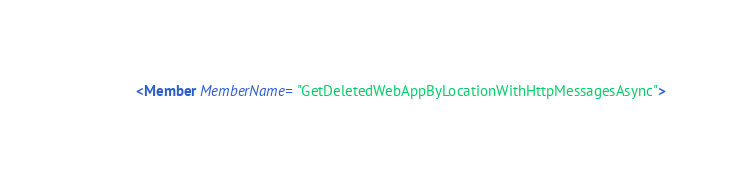Convert code to text. <code><loc_0><loc_0><loc_500><loc_500><_XML_>    <Member MemberName="GetDeletedWebAppByLocationWithHttpMessagesAsync"></code> 